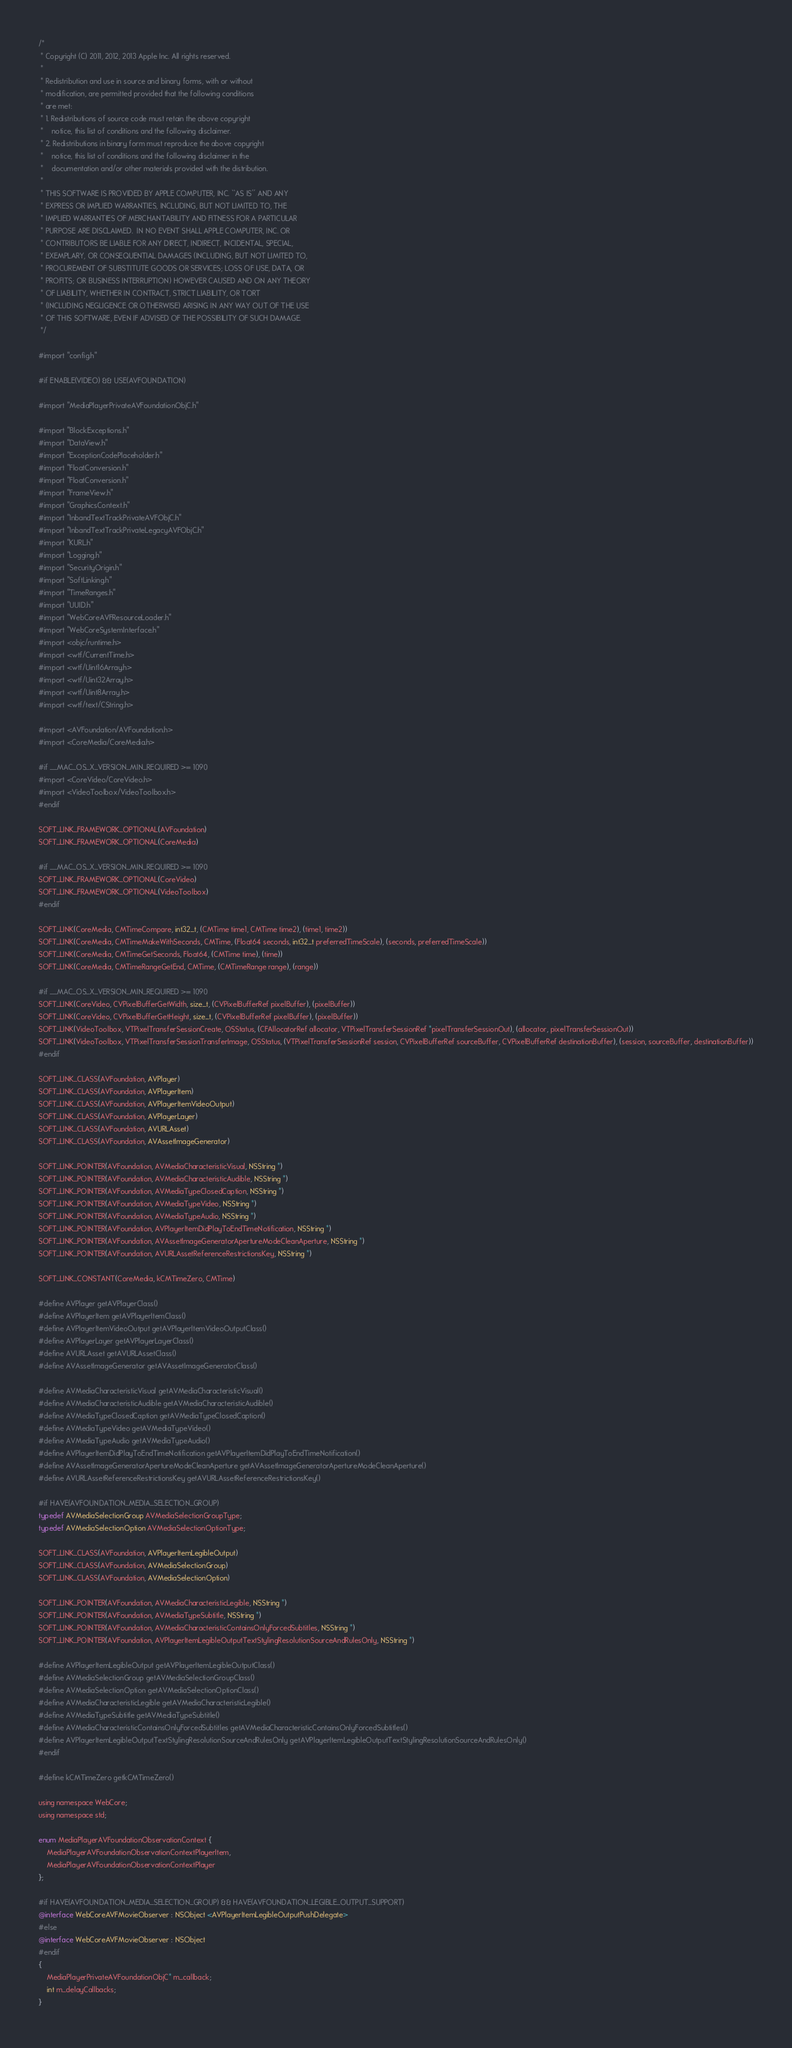Convert code to text. <code><loc_0><loc_0><loc_500><loc_500><_ObjectiveC_>/*
 * Copyright (C) 2011, 2012, 2013 Apple Inc. All rights reserved.
 *
 * Redistribution and use in source and binary forms, with or without
 * modification, are permitted provided that the following conditions
 * are met:
 * 1. Redistributions of source code must retain the above copyright
 *    notice, this list of conditions and the following disclaimer.
 * 2. Redistributions in binary form must reproduce the above copyright
 *    notice, this list of conditions and the following disclaimer in the
 *    documentation and/or other materials provided with the distribution.
 *
 * THIS SOFTWARE IS PROVIDED BY APPLE COMPUTER, INC. ``AS IS'' AND ANY
 * EXPRESS OR IMPLIED WARRANTIES, INCLUDING, BUT NOT LIMITED TO, THE
 * IMPLIED WARRANTIES OF MERCHANTABILITY AND FITNESS FOR A PARTICULAR
 * PURPOSE ARE DISCLAIMED.  IN NO EVENT SHALL APPLE COMPUTER, INC. OR
 * CONTRIBUTORS BE LIABLE FOR ANY DIRECT, INDIRECT, INCIDENTAL, SPECIAL,
 * EXEMPLARY, OR CONSEQUENTIAL DAMAGES (INCLUDING, BUT NOT LIMITED TO,
 * PROCUREMENT OF SUBSTITUTE GOODS OR SERVICES; LOSS OF USE, DATA, OR
 * PROFITS; OR BUSINESS INTERRUPTION) HOWEVER CAUSED AND ON ANY THEORY
 * OF LIABILITY, WHETHER IN CONTRACT, STRICT LIABILITY, OR TORT
 * (INCLUDING NEGLIGENCE OR OTHERWISE) ARISING IN ANY WAY OUT OF THE USE
 * OF THIS SOFTWARE, EVEN IF ADVISED OF THE POSSIBILITY OF SUCH DAMAGE. 
 */

#import "config.h"

#if ENABLE(VIDEO) && USE(AVFOUNDATION)

#import "MediaPlayerPrivateAVFoundationObjC.h"

#import "BlockExceptions.h"
#import "DataView.h"
#import "ExceptionCodePlaceholder.h"
#import "FloatConversion.h"
#import "FloatConversion.h"
#import "FrameView.h"
#import "GraphicsContext.h"
#import "InbandTextTrackPrivateAVFObjC.h"
#import "InbandTextTrackPrivateLegacyAVFObjC.h"
#import "KURL.h"
#import "Logging.h"
#import "SecurityOrigin.h"
#import "SoftLinking.h"
#import "TimeRanges.h"
#import "UUID.h"
#import "WebCoreAVFResourceLoader.h"
#import "WebCoreSystemInterface.h"
#import <objc/runtime.h>
#import <wtf/CurrentTime.h>
#import <wtf/Uint16Array.h>
#import <wtf/Uint32Array.h>
#import <wtf/Uint8Array.h>
#import <wtf/text/CString.h>

#import <AVFoundation/AVFoundation.h>
#import <CoreMedia/CoreMedia.h>

#if __MAC_OS_X_VERSION_MIN_REQUIRED >= 1090
#import <CoreVideo/CoreVideo.h>
#import <VideoToolbox/VideoToolbox.h>
#endif

SOFT_LINK_FRAMEWORK_OPTIONAL(AVFoundation)
SOFT_LINK_FRAMEWORK_OPTIONAL(CoreMedia)

#if __MAC_OS_X_VERSION_MIN_REQUIRED >= 1090
SOFT_LINK_FRAMEWORK_OPTIONAL(CoreVideo)
SOFT_LINK_FRAMEWORK_OPTIONAL(VideoToolbox)
#endif

SOFT_LINK(CoreMedia, CMTimeCompare, int32_t, (CMTime time1, CMTime time2), (time1, time2))
SOFT_LINK(CoreMedia, CMTimeMakeWithSeconds, CMTime, (Float64 seconds, int32_t preferredTimeScale), (seconds, preferredTimeScale))
SOFT_LINK(CoreMedia, CMTimeGetSeconds, Float64, (CMTime time), (time))
SOFT_LINK(CoreMedia, CMTimeRangeGetEnd, CMTime, (CMTimeRange range), (range))

#if __MAC_OS_X_VERSION_MIN_REQUIRED >= 1090
SOFT_LINK(CoreVideo, CVPixelBufferGetWidth, size_t, (CVPixelBufferRef pixelBuffer), (pixelBuffer))
SOFT_LINK(CoreVideo, CVPixelBufferGetHeight, size_t, (CVPixelBufferRef pixelBuffer), (pixelBuffer))
SOFT_LINK(VideoToolbox, VTPixelTransferSessionCreate, OSStatus, (CFAllocatorRef allocator, VTPixelTransferSessionRef *pixelTransferSessionOut), (allocator, pixelTransferSessionOut))
SOFT_LINK(VideoToolbox, VTPixelTransferSessionTransferImage, OSStatus, (VTPixelTransferSessionRef session, CVPixelBufferRef sourceBuffer, CVPixelBufferRef destinationBuffer), (session, sourceBuffer, destinationBuffer))
#endif

SOFT_LINK_CLASS(AVFoundation, AVPlayer)
SOFT_LINK_CLASS(AVFoundation, AVPlayerItem)
SOFT_LINK_CLASS(AVFoundation, AVPlayerItemVideoOutput)
SOFT_LINK_CLASS(AVFoundation, AVPlayerLayer)
SOFT_LINK_CLASS(AVFoundation, AVURLAsset)
SOFT_LINK_CLASS(AVFoundation, AVAssetImageGenerator)

SOFT_LINK_POINTER(AVFoundation, AVMediaCharacteristicVisual, NSString *)
SOFT_LINK_POINTER(AVFoundation, AVMediaCharacteristicAudible, NSString *)
SOFT_LINK_POINTER(AVFoundation, AVMediaTypeClosedCaption, NSString *)
SOFT_LINK_POINTER(AVFoundation, AVMediaTypeVideo, NSString *)
SOFT_LINK_POINTER(AVFoundation, AVMediaTypeAudio, NSString *)
SOFT_LINK_POINTER(AVFoundation, AVPlayerItemDidPlayToEndTimeNotification, NSString *)
SOFT_LINK_POINTER(AVFoundation, AVAssetImageGeneratorApertureModeCleanAperture, NSString *)
SOFT_LINK_POINTER(AVFoundation, AVURLAssetReferenceRestrictionsKey, NSString *)

SOFT_LINK_CONSTANT(CoreMedia, kCMTimeZero, CMTime)

#define AVPlayer getAVPlayerClass()
#define AVPlayerItem getAVPlayerItemClass()
#define AVPlayerItemVideoOutput getAVPlayerItemVideoOutputClass()
#define AVPlayerLayer getAVPlayerLayerClass()
#define AVURLAsset getAVURLAssetClass()
#define AVAssetImageGenerator getAVAssetImageGeneratorClass()

#define AVMediaCharacteristicVisual getAVMediaCharacteristicVisual()
#define AVMediaCharacteristicAudible getAVMediaCharacteristicAudible()
#define AVMediaTypeClosedCaption getAVMediaTypeClosedCaption()
#define AVMediaTypeVideo getAVMediaTypeVideo()
#define AVMediaTypeAudio getAVMediaTypeAudio()
#define AVPlayerItemDidPlayToEndTimeNotification getAVPlayerItemDidPlayToEndTimeNotification()
#define AVAssetImageGeneratorApertureModeCleanAperture getAVAssetImageGeneratorApertureModeCleanAperture()
#define AVURLAssetReferenceRestrictionsKey getAVURLAssetReferenceRestrictionsKey()

#if HAVE(AVFOUNDATION_MEDIA_SELECTION_GROUP)
typedef AVMediaSelectionGroup AVMediaSelectionGroupType;
typedef AVMediaSelectionOption AVMediaSelectionOptionType;

SOFT_LINK_CLASS(AVFoundation, AVPlayerItemLegibleOutput)
SOFT_LINK_CLASS(AVFoundation, AVMediaSelectionGroup)
SOFT_LINK_CLASS(AVFoundation, AVMediaSelectionOption)

SOFT_LINK_POINTER(AVFoundation, AVMediaCharacteristicLegible, NSString *)
SOFT_LINK_POINTER(AVFoundation, AVMediaTypeSubtitle, NSString *)
SOFT_LINK_POINTER(AVFoundation, AVMediaCharacteristicContainsOnlyForcedSubtitles, NSString *)
SOFT_LINK_POINTER(AVFoundation, AVPlayerItemLegibleOutputTextStylingResolutionSourceAndRulesOnly, NSString *)

#define AVPlayerItemLegibleOutput getAVPlayerItemLegibleOutputClass()
#define AVMediaSelectionGroup getAVMediaSelectionGroupClass()
#define AVMediaSelectionOption getAVMediaSelectionOptionClass()
#define AVMediaCharacteristicLegible getAVMediaCharacteristicLegible()
#define AVMediaTypeSubtitle getAVMediaTypeSubtitle()
#define AVMediaCharacteristicContainsOnlyForcedSubtitles getAVMediaCharacteristicContainsOnlyForcedSubtitles()
#define AVPlayerItemLegibleOutputTextStylingResolutionSourceAndRulesOnly getAVPlayerItemLegibleOutputTextStylingResolutionSourceAndRulesOnly()
#endif

#define kCMTimeZero getkCMTimeZero()

using namespace WebCore;
using namespace std;

enum MediaPlayerAVFoundationObservationContext {
    MediaPlayerAVFoundationObservationContextPlayerItem,
    MediaPlayerAVFoundationObservationContextPlayer
};

#if HAVE(AVFOUNDATION_MEDIA_SELECTION_GROUP) && HAVE(AVFOUNDATION_LEGIBLE_OUTPUT_SUPPORT)
@interface WebCoreAVFMovieObserver : NSObject <AVPlayerItemLegibleOutputPushDelegate>
#else
@interface WebCoreAVFMovieObserver : NSObject
#endif
{
    MediaPlayerPrivateAVFoundationObjC* m_callback;
    int m_delayCallbacks;
}</code> 